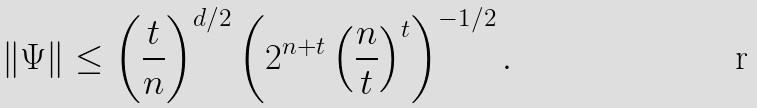<formula> <loc_0><loc_0><loc_500><loc_500>\| \Psi \| \leq \left ( \frac { t } { n } \right ) ^ { d / 2 } \left ( 2 ^ { n + t } \left ( \frac { n } { t } \right ) ^ { t } \right ) ^ { - 1 / 2 } .</formula> 